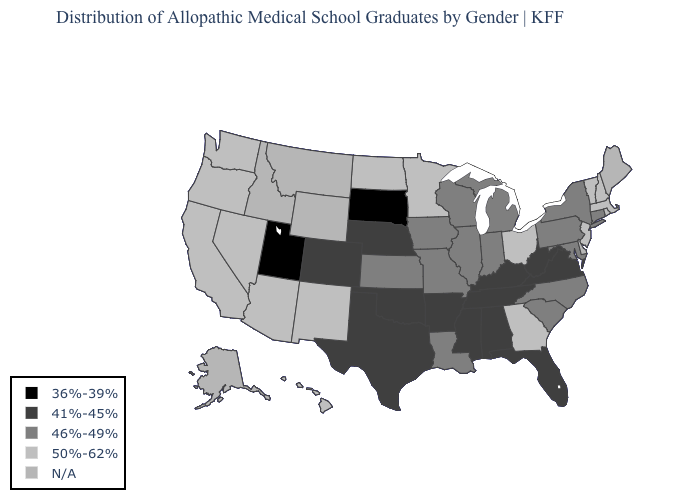Name the states that have a value in the range N/A?
Quick response, please. Alaska, Delaware, Idaho, Maine, Montana, Wyoming. What is the lowest value in the West?
Answer briefly. 36%-39%. What is the value of Wyoming?
Give a very brief answer. N/A. Does the map have missing data?
Quick response, please. Yes. Does the first symbol in the legend represent the smallest category?
Keep it brief. Yes. What is the highest value in the USA?
Keep it brief. 50%-62%. What is the highest value in states that border Washington?
Keep it brief. 50%-62%. Name the states that have a value in the range 50%-62%?
Short answer required. Arizona, California, Georgia, Hawaii, Massachusetts, Minnesota, Nevada, New Hampshire, New Jersey, New Mexico, North Dakota, Ohio, Oregon, Rhode Island, Vermont, Washington. What is the value of New Jersey?
Give a very brief answer. 50%-62%. What is the value of Wisconsin?
Be succinct. 46%-49%. What is the highest value in states that border Pennsylvania?
Write a very short answer. 50%-62%. Does Massachusetts have the highest value in the Northeast?
Concise answer only. Yes. 